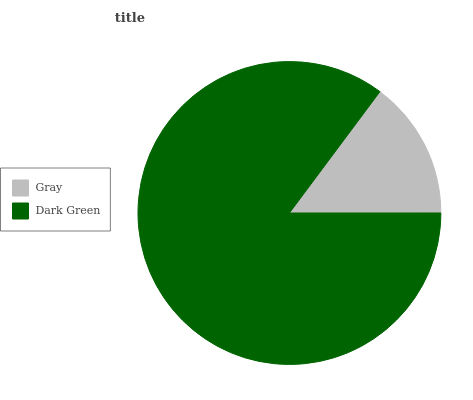Is Gray the minimum?
Answer yes or no. Yes. Is Dark Green the maximum?
Answer yes or no. Yes. Is Dark Green the minimum?
Answer yes or no. No. Is Dark Green greater than Gray?
Answer yes or no. Yes. Is Gray less than Dark Green?
Answer yes or no. Yes. Is Gray greater than Dark Green?
Answer yes or no. No. Is Dark Green less than Gray?
Answer yes or no. No. Is Dark Green the high median?
Answer yes or no. Yes. Is Gray the low median?
Answer yes or no. Yes. Is Gray the high median?
Answer yes or no. No. Is Dark Green the low median?
Answer yes or no. No. 